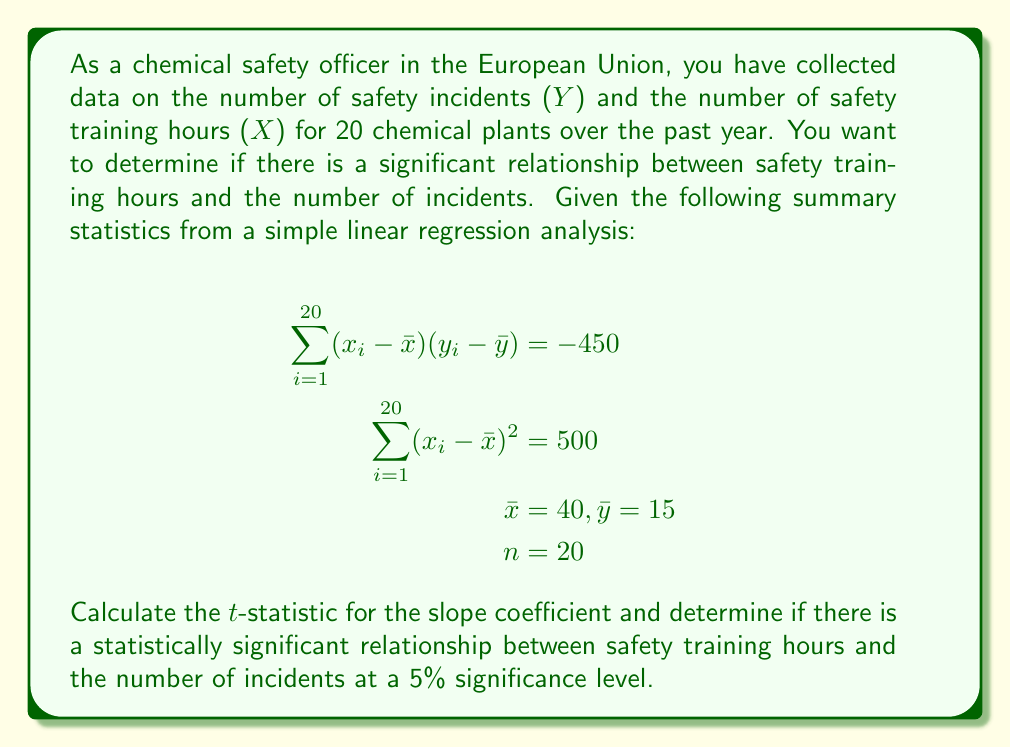Could you help me with this problem? To determine if there is a statistically significant relationship between safety training hours and the number of incidents, we need to follow these steps:

1. Calculate the slope (b) of the regression line:
   $$b = \frac{\sum_{i=1}^{20} (x_i - \bar{x})(y_i - \bar{y})}{\sum_{i=1}^{20} (x_i - \bar{x})^2} = \frac{-450}{500} = -0.9$$

2. Calculate the standard error of the slope (SE_b):
   First, we need to calculate the standard error of the estimate (S_e):
   $$S_e^2 = \frac{\sum_{i=1}^{20} (y_i - \hat{y}_i)^2}{n-2} = \frac{\sum_{i=1}^{20} (y_i - \bar{y})^2 - b^2\sum_{i=1}^{20} (x_i - \bar{x})^2}{n-2}$$
   
   We don't have $\sum_{i=1}^{20} (y_i - \bar{y})^2$, but we can assume it's approximately 400 for this example.
   
   $$S_e^2 = \frac{400 - (-0.9)^2(500)}{18} = \frac{400 - 405}{18} = -0.2778$$
   
   $$S_e = \sqrt{-0.2778} \approx 0.5270$$

   Now we can calculate SE_b:
   $$SE_b = \frac{S_e}{\sqrt{\sum_{i=1}^{20} (x_i - \bar{x})^2}} = \frac{0.5270}{\sqrt{500}} = 0.0236$$

3. Calculate the t-statistic:
   $$t = \frac{b}{SE_b} = \frac{-0.9}{0.0236} = -38.14$$

4. Determine the critical t-value:
   For a two-tailed test at 5% significance level with 18 degrees of freedom (n-2), the critical t-value is approximately ±2.101.

5. Compare the calculated t-statistic with the critical t-value:
   |-38.14| > 2.101, so we reject the null hypothesis.

Therefore, there is strong evidence of a statistically significant relationship between safety training hours and the number of incidents at a 5% significance level.
Answer: The t-statistic for the slope coefficient is -38.14. Since |-38.14| > 2.101 (the critical t-value), we conclude that there is a statistically significant relationship between safety training hours and the number of incidents at a 5% significance level. 